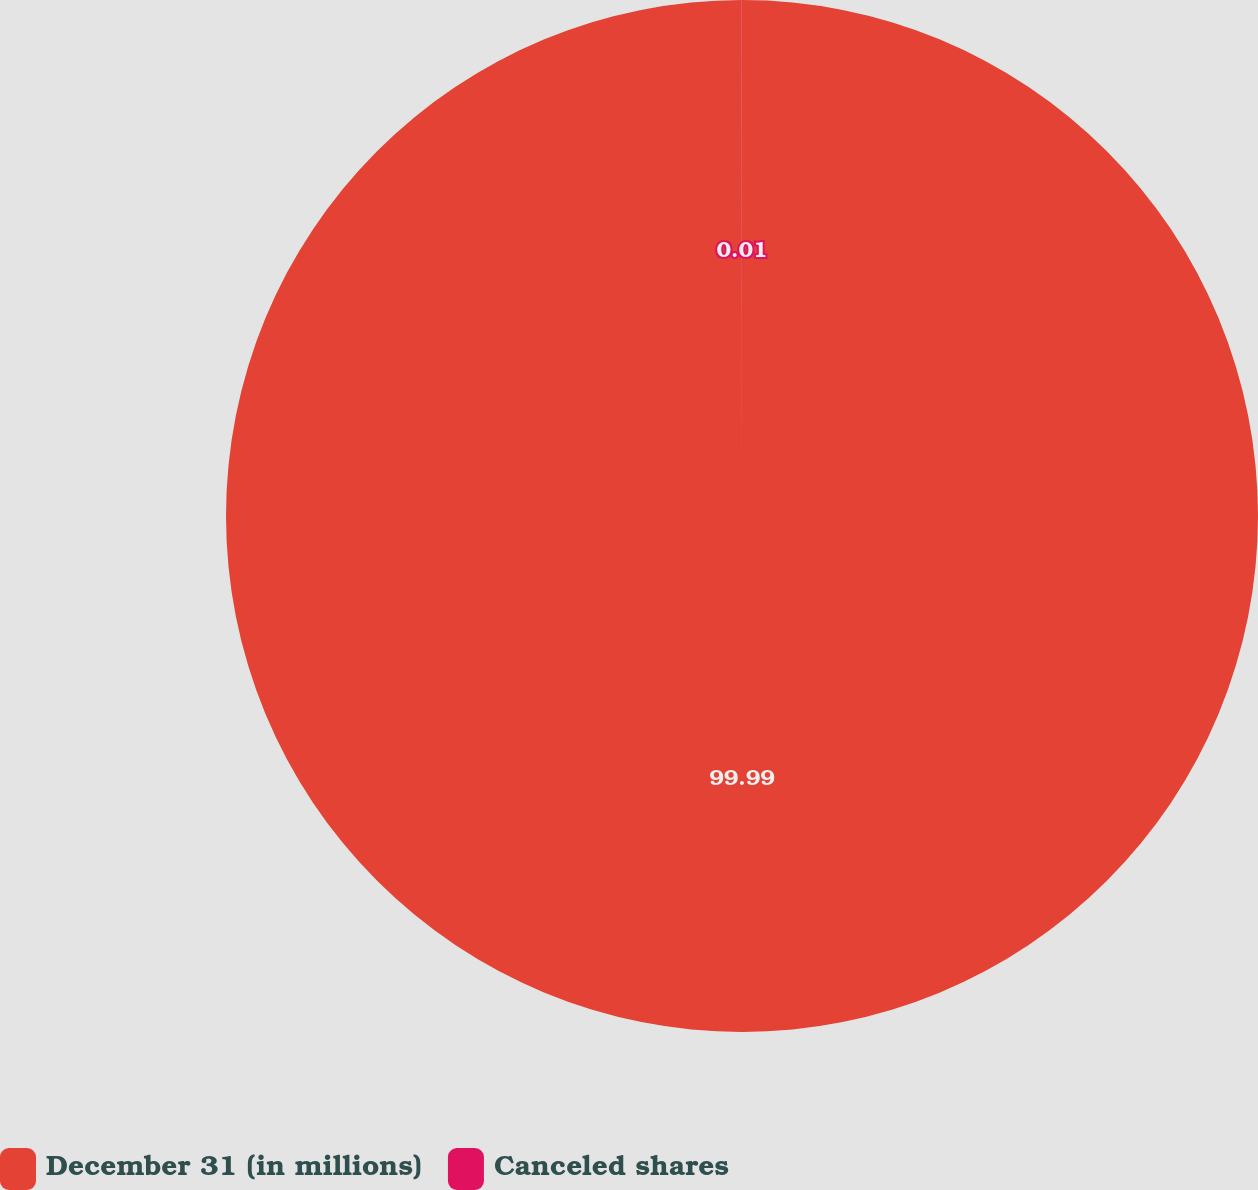Convert chart to OTSL. <chart><loc_0><loc_0><loc_500><loc_500><pie_chart><fcel>December 31 (in millions)<fcel>Canceled shares<nl><fcel>99.99%<fcel>0.01%<nl></chart> 